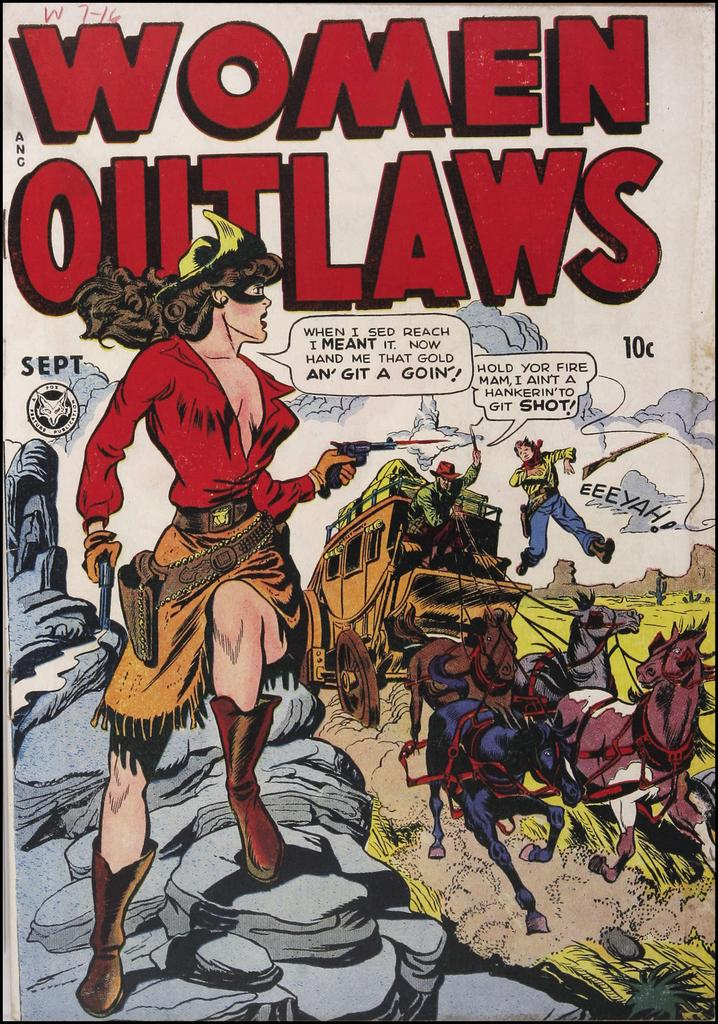Provide a one-sentence caption for the provided image. The September edition of the comic series Women Outlaws. 